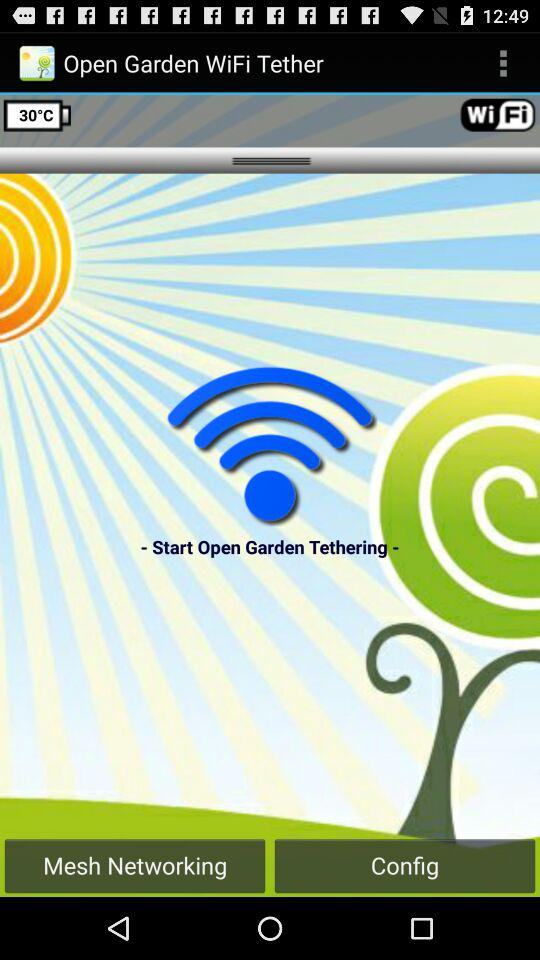What is the name of the application? The name of the application is "Open Garden WiFi Tether". 